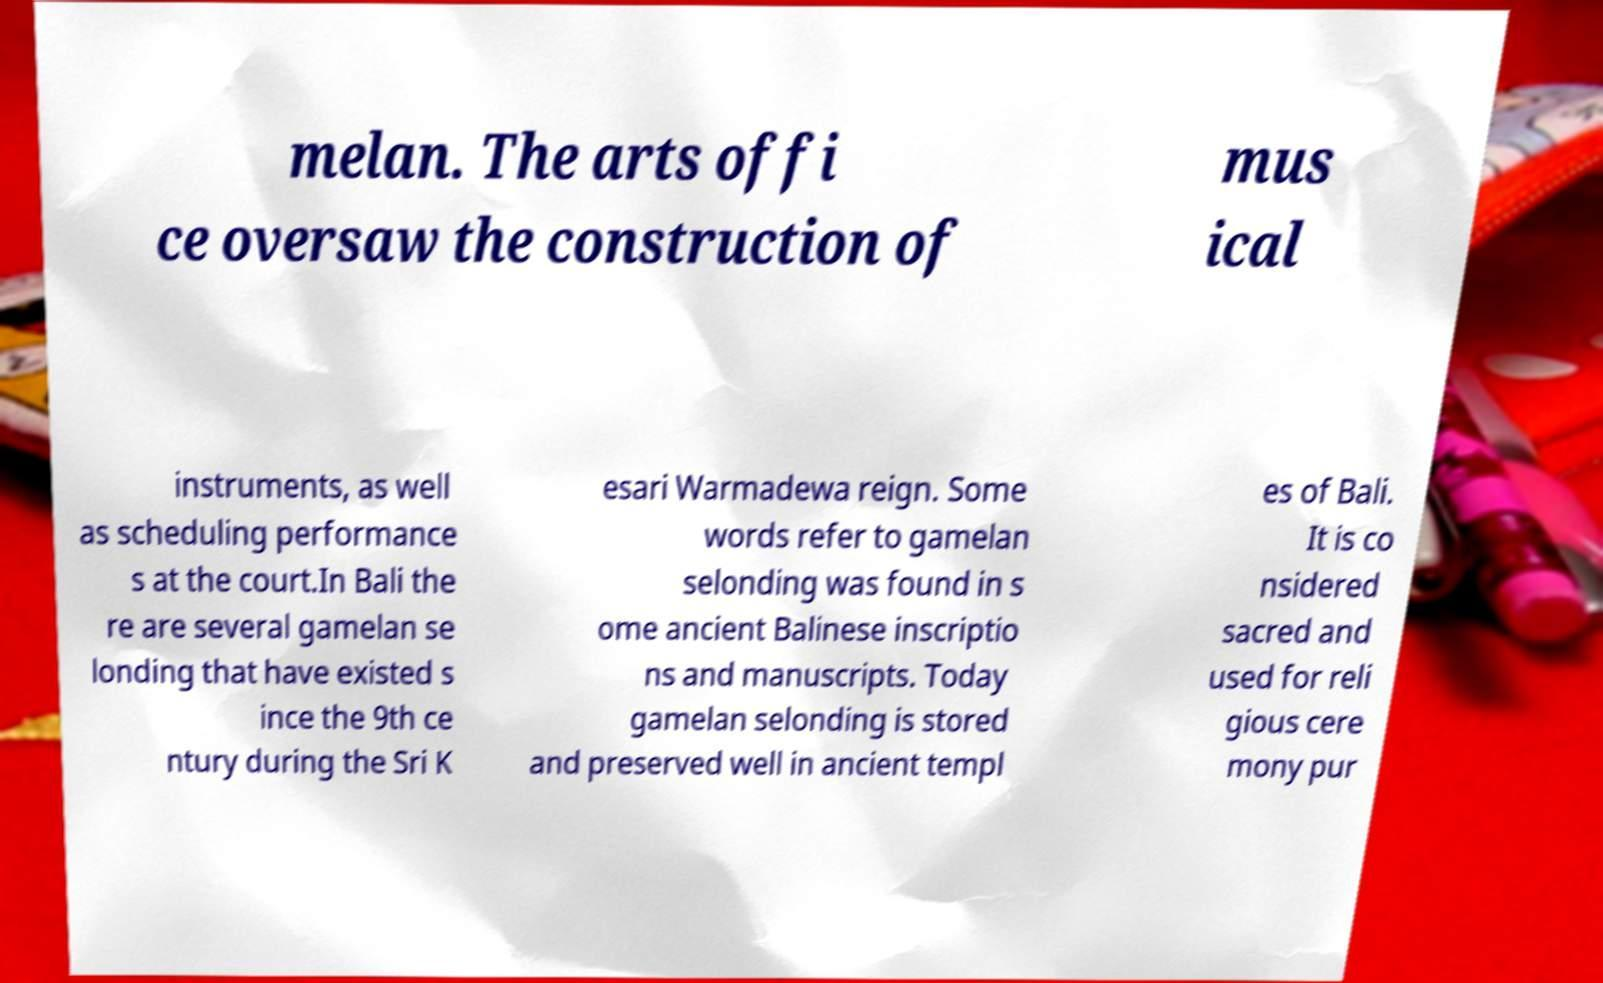What messages or text are displayed in this image? I need them in a readable, typed format. melan. The arts offi ce oversaw the construction of mus ical instruments, as well as scheduling performance s at the court.In Bali the re are several gamelan se londing that have existed s ince the 9th ce ntury during the Sri K esari Warmadewa reign. Some words refer to gamelan selonding was found in s ome ancient Balinese inscriptio ns and manuscripts. Today gamelan selonding is stored and preserved well in ancient templ es of Bali. It is co nsidered sacred and used for reli gious cere mony pur 